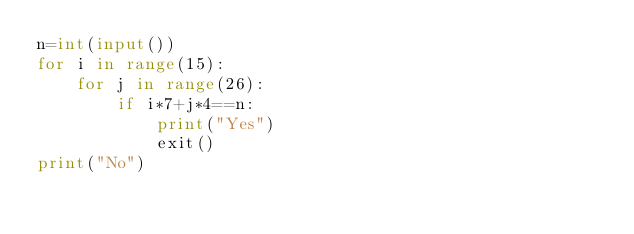<code> <loc_0><loc_0><loc_500><loc_500><_Python_>n=int(input())
for i in range(15):
    for j in range(26):
        if i*7+j*4==n:
            print("Yes")
            exit()
print("No")
</code> 